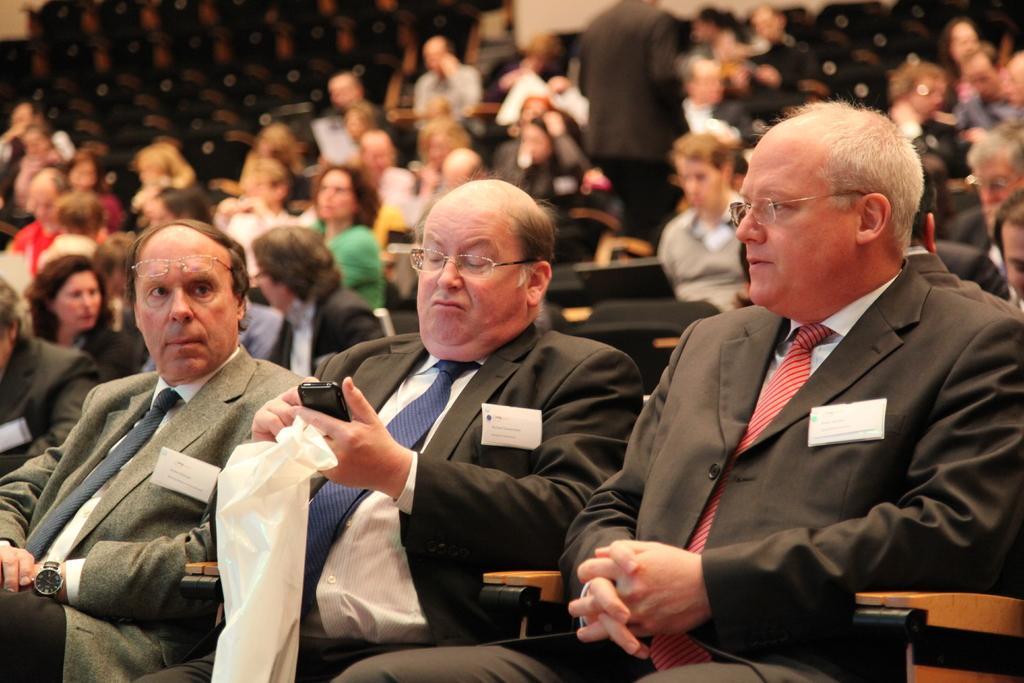How would you summarize this image in a sentence or two? In the picture we can see many people are sitting in the auditorium and three men are in blazers, ties and shirts and one man is holding a cloth. 